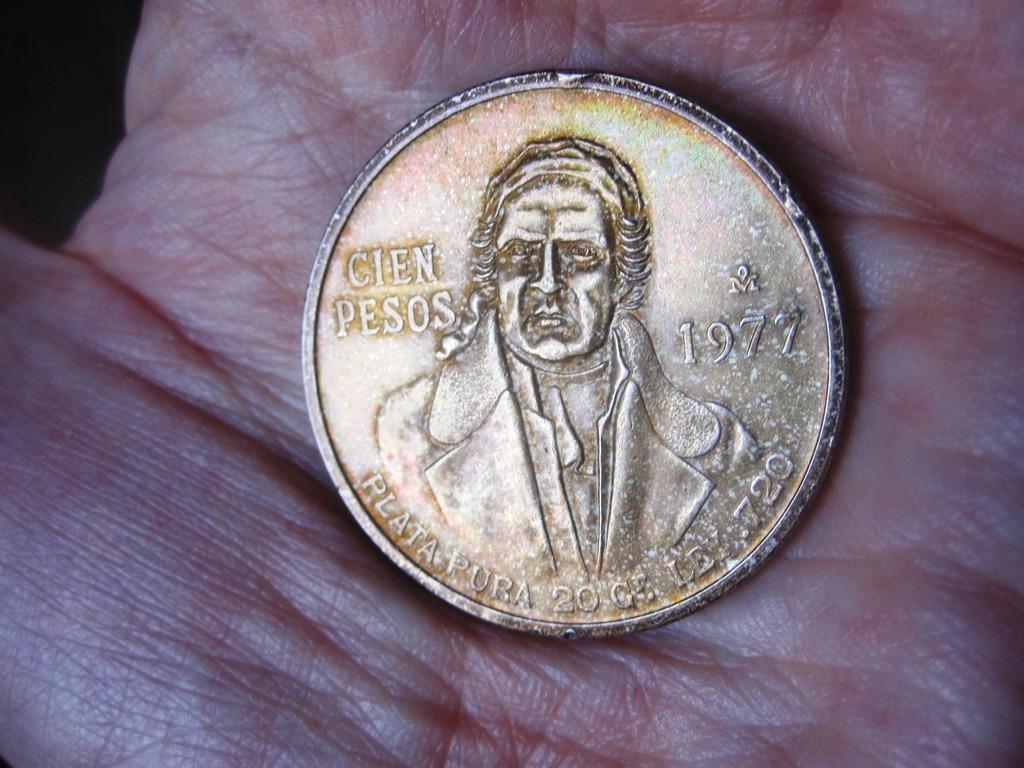<image>
Render a clear and concise summary of the photo. An old coin minted in 1977 is in a palm of a hand. 